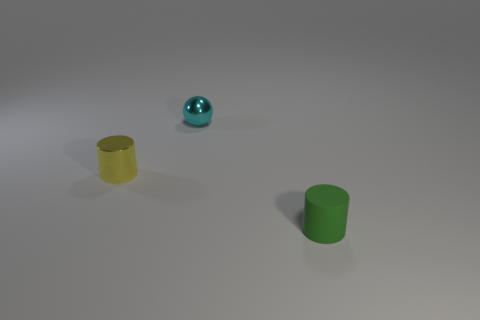Add 3 small things. How many objects exist? 6 Subtract all balls. How many objects are left? 2 Add 1 cyan spheres. How many cyan spheres are left? 2 Add 2 small blue shiny cubes. How many small blue shiny cubes exist? 2 Subtract 0 purple balls. How many objects are left? 3 Subtract all purple metallic things. Subtract all tiny cyan balls. How many objects are left? 2 